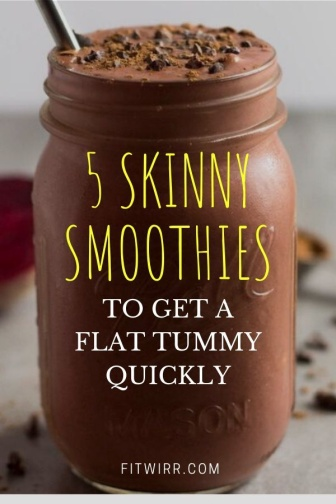Describe how the design and typography in the image could affect viewer perception. The use of bold yellow typography with a dynamic size variation in the text emphasizes the key message of the image, making it more eye-catching and engaging. The large, highlighted word 'SKINNY' conveys an immediate sense of health and fitness goals. The simple yet striking design elements, like the clean background and focused lighting on the smoothie, direct the viewer's attention effectively to the product, promising both taste and health benefits. The overall aesthetic might persuade viewers to perceive the smoothie as not just nutritious, but also as a fashionable lifestyle choice. 